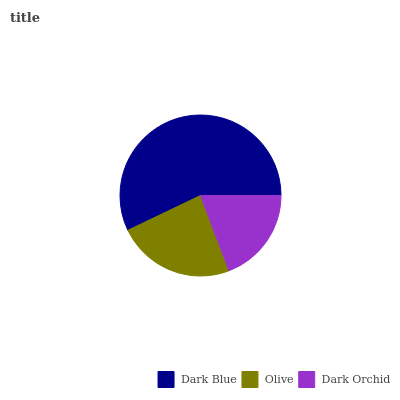Is Dark Orchid the minimum?
Answer yes or no. Yes. Is Dark Blue the maximum?
Answer yes or no. Yes. Is Olive the minimum?
Answer yes or no. No. Is Olive the maximum?
Answer yes or no. No. Is Dark Blue greater than Olive?
Answer yes or no. Yes. Is Olive less than Dark Blue?
Answer yes or no. Yes. Is Olive greater than Dark Blue?
Answer yes or no. No. Is Dark Blue less than Olive?
Answer yes or no. No. Is Olive the high median?
Answer yes or no. Yes. Is Olive the low median?
Answer yes or no. Yes. Is Dark Blue the high median?
Answer yes or no. No. Is Dark Orchid the low median?
Answer yes or no. No. 